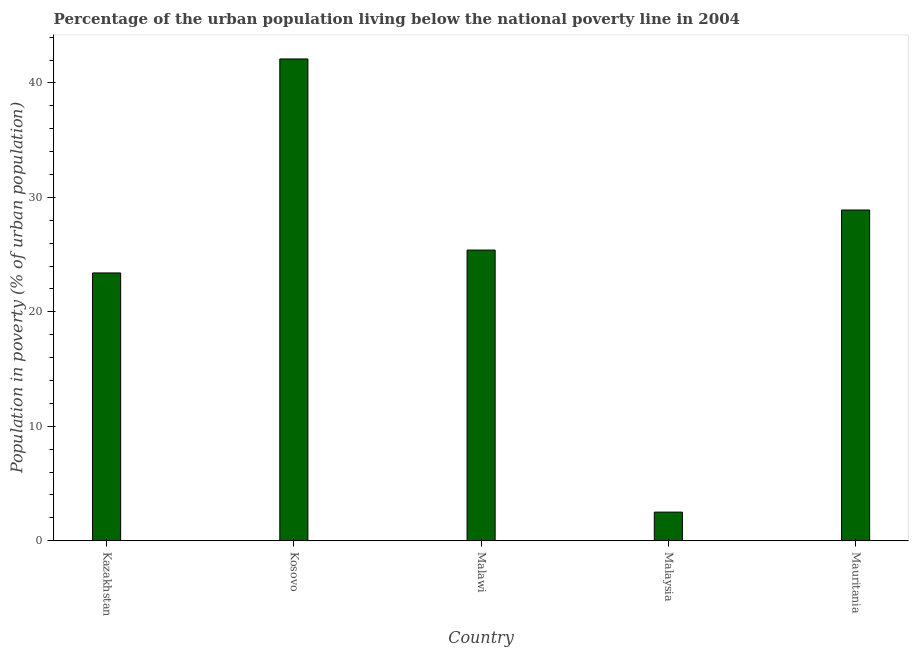Does the graph contain grids?
Offer a terse response. No. What is the title of the graph?
Your answer should be very brief. Percentage of the urban population living below the national poverty line in 2004. What is the label or title of the X-axis?
Your answer should be very brief. Country. What is the label or title of the Y-axis?
Make the answer very short. Population in poverty (% of urban population). Across all countries, what is the maximum percentage of urban population living below poverty line?
Provide a short and direct response. 42.1. In which country was the percentage of urban population living below poverty line maximum?
Keep it short and to the point. Kosovo. In which country was the percentage of urban population living below poverty line minimum?
Give a very brief answer. Malaysia. What is the sum of the percentage of urban population living below poverty line?
Provide a succinct answer. 122.3. What is the difference between the percentage of urban population living below poverty line in Kazakhstan and Malawi?
Provide a succinct answer. -2. What is the average percentage of urban population living below poverty line per country?
Offer a very short reply. 24.46. What is the median percentage of urban population living below poverty line?
Offer a very short reply. 25.4. What is the ratio of the percentage of urban population living below poverty line in Kazakhstan to that in Kosovo?
Give a very brief answer. 0.56. Is the difference between the percentage of urban population living below poverty line in Malaysia and Mauritania greater than the difference between any two countries?
Keep it short and to the point. No. Is the sum of the percentage of urban population living below poverty line in Kazakhstan and Kosovo greater than the maximum percentage of urban population living below poverty line across all countries?
Your response must be concise. Yes. What is the difference between the highest and the lowest percentage of urban population living below poverty line?
Provide a short and direct response. 39.6. In how many countries, is the percentage of urban population living below poverty line greater than the average percentage of urban population living below poverty line taken over all countries?
Your answer should be compact. 3. Are all the bars in the graph horizontal?
Give a very brief answer. No. How many countries are there in the graph?
Ensure brevity in your answer.  5. What is the difference between two consecutive major ticks on the Y-axis?
Your response must be concise. 10. Are the values on the major ticks of Y-axis written in scientific E-notation?
Your response must be concise. No. What is the Population in poverty (% of urban population) in Kazakhstan?
Provide a succinct answer. 23.4. What is the Population in poverty (% of urban population) of Kosovo?
Your answer should be very brief. 42.1. What is the Population in poverty (% of urban population) in Malawi?
Offer a very short reply. 25.4. What is the Population in poverty (% of urban population) in Mauritania?
Ensure brevity in your answer.  28.9. What is the difference between the Population in poverty (% of urban population) in Kazakhstan and Kosovo?
Offer a very short reply. -18.7. What is the difference between the Population in poverty (% of urban population) in Kazakhstan and Malaysia?
Your answer should be compact. 20.9. What is the difference between the Population in poverty (% of urban population) in Kazakhstan and Mauritania?
Your answer should be very brief. -5.5. What is the difference between the Population in poverty (% of urban population) in Kosovo and Malawi?
Your answer should be compact. 16.7. What is the difference between the Population in poverty (% of urban population) in Kosovo and Malaysia?
Your answer should be compact. 39.6. What is the difference between the Population in poverty (% of urban population) in Kosovo and Mauritania?
Your answer should be very brief. 13.2. What is the difference between the Population in poverty (% of urban population) in Malawi and Malaysia?
Ensure brevity in your answer.  22.9. What is the difference between the Population in poverty (% of urban population) in Malaysia and Mauritania?
Ensure brevity in your answer.  -26.4. What is the ratio of the Population in poverty (% of urban population) in Kazakhstan to that in Kosovo?
Make the answer very short. 0.56. What is the ratio of the Population in poverty (% of urban population) in Kazakhstan to that in Malawi?
Keep it short and to the point. 0.92. What is the ratio of the Population in poverty (% of urban population) in Kazakhstan to that in Malaysia?
Give a very brief answer. 9.36. What is the ratio of the Population in poverty (% of urban population) in Kazakhstan to that in Mauritania?
Give a very brief answer. 0.81. What is the ratio of the Population in poverty (% of urban population) in Kosovo to that in Malawi?
Keep it short and to the point. 1.66. What is the ratio of the Population in poverty (% of urban population) in Kosovo to that in Malaysia?
Ensure brevity in your answer.  16.84. What is the ratio of the Population in poverty (% of urban population) in Kosovo to that in Mauritania?
Your response must be concise. 1.46. What is the ratio of the Population in poverty (% of urban population) in Malawi to that in Malaysia?
Your response must be concise. 10.16. What is the ratio of the Population in poverty (% of urban population) in Malawi to that in Mauritania?
Your answer should be very brief. 0.88. What is the ratio of the Population in poverty (% of urban population) in Malaysia to that in Mauritania?
Provide a short and direct response. 0.09. 